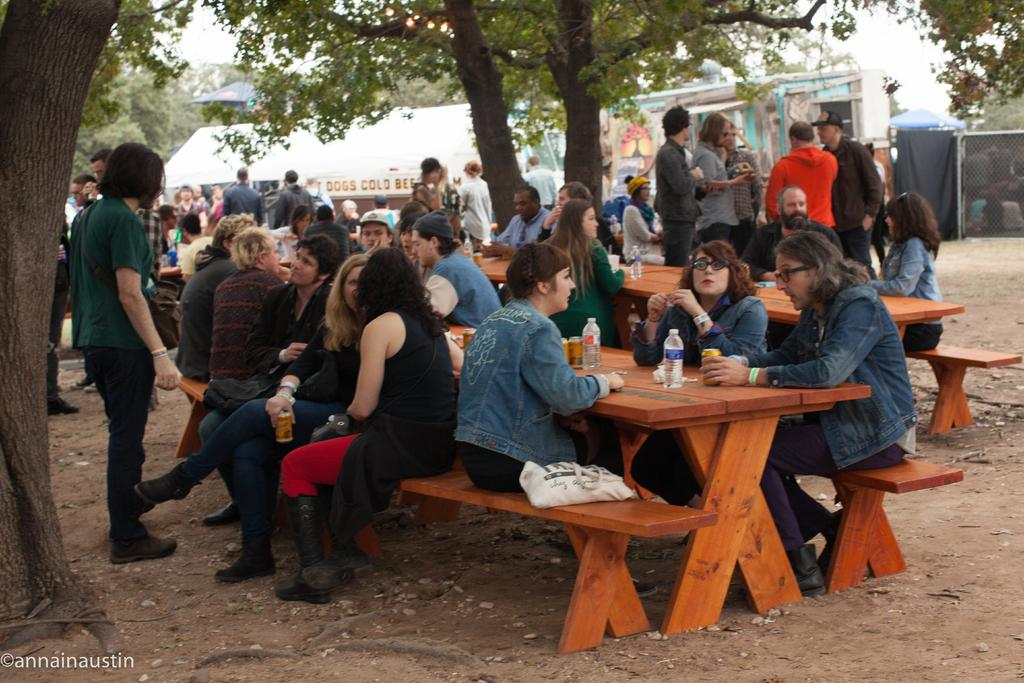What are the people in the image doing? The people in the image are sitting together on benches. What activity are the people engaged in? The people are drinking drinks. In which direction is the river flowing in the image? There is no river present in the image. What type of match is being played by the people in the image? There is no match being played in the image; the people are simply sitting together and drinking drinks. 